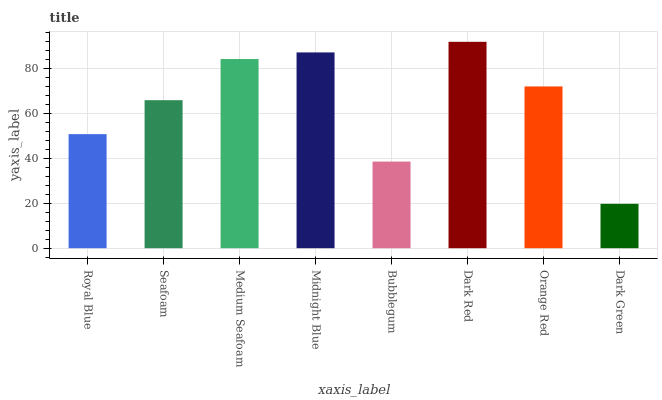Is Dark Green the minimum?
Answer yes or no. Yes. Is Dark Red the maximum?
Answer yes or no. Yes. Is Seafoam the minimum?
Answer yes or no. No. Is Seafoam the maximum?
Answer yes or no. No. Is Seafoam greater than Royal Blue?
Answer yes or no. Yes. Is Royal Blue less than Seafoam?
Answer yes or no. Yes. Is Royal Blue greater than Seafoam?
Answer yes or no. No. Is Seafoam less than Royal Blue?
Answer yes or no. No. Is Orange Red the high median?
Answer yes or no. Yes. Is Seafoam the low median?
Answer yes or no. Yes. Is Bubblegum the high median?
Answer yes or no. No. Is Dark Green the low median?
Answer yes or no. No. 